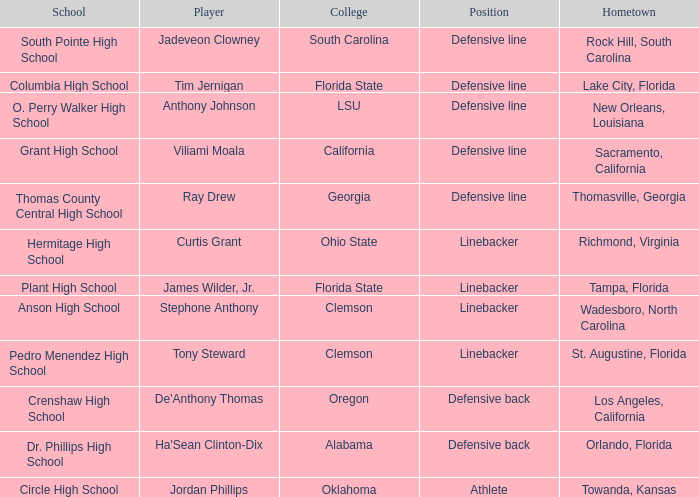Which athlete hails from tampa, florida? James Wilder, Jr. 